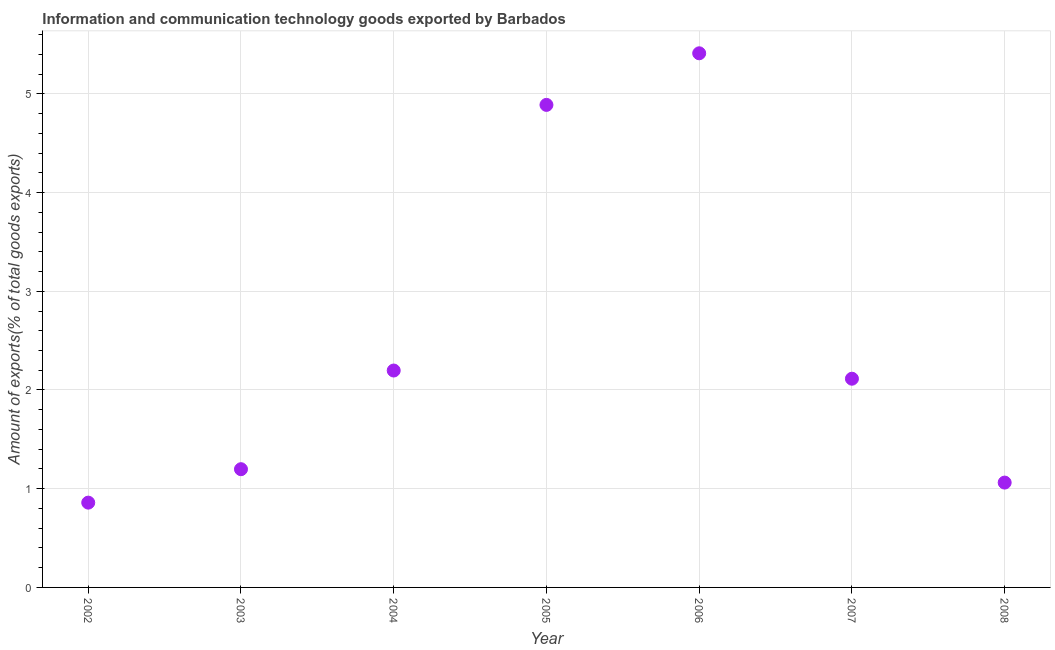What is the amount of ict goods exports in 2007?
Your answer should be compact. 2.11. Across all years, what is the maximum amount of ict goods exports?
Your answer should be compact. 5.41. Across all years, what is the minimum amount of ict goods exports?
Your answer should be compact. 0.86. In which year was the amount of ict goods exports maximum?
Provide a short and direct response. 2006. What is the sum of the amount of ict goods exports?
Offer a very short reply. 17.73. What is the difference between the amount of ict goods exports in 2005 and 2006?
Offer a very short reply. -0.52. What is the average amount of ict goods exports per year?
Your answer should be compact. 2.53. What is the median amount of ict goods exports?
Keep it short and to the point. 2.11. In how many years, is the amount of ict goods exports greater than 0.2 %?
Give a very brief answer. 7. What is the ratio of the amount of ict goods exports in 2002 to that in 2004?
Give a very brief answer. 0.39. Is the difference between the amount of ict goods exports in 2007 and 2008 greater than the difference between any two years?
Provide a short and direct response. No. What is the difference between the highest and the second highest amount of ict goods exports?
Provide a short and direct response. 0.52. Is the sum of the amount of ict goods exports in 2003 and 2008 greater than the maximum amount of ict goods exports across all years?
Make the answer very short. No. What is the difference between the highest and the lowest amount of ict goods exports?
Ensure brevity in your answer.  4.55. In how many years, is the amount of ict goods exports greater than the average amount of ict goods exports taken over all years?
Offer a very short reply. 2. How many years are there in the graph?
Offer a very short reply. 7. Are the values on the major ticks of Y-axis written in scientific E-notation?
Your answer should be very brief. No. Does the graph contain any zero values?
Offer a terse response. No. Does the graph contain grids?
Provide a short and direct response. Yes. What is the title of the graph?
Give a very brief answer. Information and communication technology goods exported by Barbados. What is the label or title of the Y-axis?
Make the answer very short. Amount of exports(% of total goods exports). What is the Amount of exports(% of total goods exports) in 2002?
Make the answer very short. 0.86. What is the Amount of exports(% of total goods exports) in 2003?
Your answer should be compact. 1.2. What is the Amount of exports(% of total goods exports) in 2004?
Give a very brief answer. 2.2. What is the Amount of exports(% of total goods exports) in 2005?
Offer a very short reply. 4.89. What is the Amount of exports(% of total goods exports) in 2006?
Ensure brevity in your answer.  5.41. What is the Amount of exports(% of total goods exports) in 2007?
Ensure brevity in your answer.  2.11. What is the Amount of exports(% of total goods exports) in 2008?
Your answer should be very brief. 1.06. What is the difference between the Amount of exports(% of total goods exports) in 2002 and 2003?
Ensure brevity in your answer.  -0.34. What is the difference between the Amount of exports(% of total goods exports) in 2002 and 2004?
Provide a succinct answer. -1.34. What is the difference between the Amount of exports(% of total goods exports) in 2002 and 2005?
Offer a terse response. -4.03. What is the difference between the Amount of exports(% of total goods exports) in 2002 and 2006?
Make the answer very short. -4.55. What is the difference between the Amount of exports(% of total goods exports) in 2002 and 2007?
Offer a terse response. -1.26. What is the difference between the Amount of exports(% of total goods exports) in 2002 and 2008?
Ensure brevity in your answer.  -0.2. What is the difference between the Amount of exports(% of total goods exports) in 2003 and 2004?
Give a very brief answer. -1. What is the difference between the Amount of exports(% of total goods exports) in 2003 and 2005?
Your answer should be compact. -3.69. What is the difference between the Amount of exports(% of total goods exports) in 2003 and 2006?
Your response must be concise. -4.21. What is the difference between the Amount of exports(% of total goods exports) in 2003 and 2007?
Make the answer very short. -0.92. What is the difference between the Amount of exports(% of total goods exports) in 2003 and 2008?
Provide a succinct answer. 0.14. What is the difference between the Amount of exports(% of total goods exports) in 2004 and 2005?
Offer a very short reply. -2.69. What is the difference between the Amount of exports(% of total goods exports) in 2004 and 2006?
Ensure brevity in your answer.  -3.21. What is the difference between the Amount of exports(% of total goods exports) in 2004 and 2007?
Keep it short and to the point. 0.08. What is the difference between the Amount of exports(% of total goods exports) in 2004 and 2008?
Offer a very short reply. 1.14. What is the difference between the Amount of exports(% of total goods exports) in 2005 and 2006?
Offer a very short reply. -0.52. What is the difference between the Amount of exports(% of total goods exports) in 2005 and 2007?
Provide a short and direct response. 2.77. What is the difference between the Amount of exports(% of total goods exports) in 2005 and 2008?
Provide a short and direct response. 3.83. What is the difference between the Amount of exports(% of total goods exports) in 2006 and 2007?
Offer a very short reply. 3.3. What is the difference between the Amount of exports(% of total goods exports) in 2006 and 2008?
Provide a succinct answer. 4.35. What is the difference between the Amount of exports(% of total goods exports) in 2007 and 2008?
Provide a succinct answer. 1.05. What is the ratio of the Amount of exports(% of total goods exports) in 2002 to that in 2003?
Make the answer very short. 0.72. What is the ratio of the Amount of exports(% of total goods exports) in 2002 to that in 2004?
Provide a succinct answer. 0.39. What is the ratio of the Amount of exports(% of total goods exports) in 2002 to that in 2005?
Provide a short and direct response. 0.18. What is the ratio of the Amount of exports(% of total goods exports) in 2002 to that in 2006?
Your answer should be very brief. 0.16. What is the ratio of the Amount of exports(% of total goods exports) in 2002 to that in 2007?
Offer a very short reply. 0.41. What is the ratio of the Amount of exports(% of total goods exports) in 2002 to that in 2008?
Offer a terse response. 0.81. What is the ratio of the Amount of exports(% of total goods exports) in 2003 to that in 2004?
Your response must be concise. 0.55. What is the ratio of the Amount of exports(% of total goods exports) in 2003 to that in 2005?
Provide a succinct answer. 0.24. What is the ratio of the Amount of exports(% of total goods exports) in 2003 to that in 2006?
Offer a very short reply. 0.22. What is the ratio of the Amount of exports(% of total goods exports) in 2003 to that in 2007?
Provide a short and direct response. 0.57. What is the ratio of the Amount of exports(% of total goods exports) in 2003 to that in 2008?
Your response must be concise. 1.13. What is the ratio of the Amount of exports(% of total goods exports) in 2004 to that in 2005?
Make the answer very short. 0.45. What is the ratio of the Amount of exports(% of total goods exports) in 2004 to that in 2006?
Offer a terse response. 0.41. What is the ratio of the Amount of exports(% of total goods exports) in 2004 to that in 2007?
Your answer should be compact. 1.04. What is the ratio of the Amount of exports(% of total goods exports) in 2004 to that in 2008?
Your answer should be compact. 2.07. What is the ratio of the Amount of exports(% of total goods exports) in 2005 to that in 2006?
Give a very brief answer. 0.9. What is the ratio of the Amount of exports(% of total goods exports) in 2005 to that in 2007?
Your answer should be very brief. 2.31. What is the ratio of the Amount of exports(% of total goods exports) in 2005 to that in 2008?
Ensure brevity in your answer.  4.6. What is the ratio of the Amount of exports(% of total goods exports) in 2006 to that in 2007?
Offer a very short reply. 2.56. What is the ratio of the Amount of exports(% of total goods exports) in 2006 to that in 2008?
Your answer should be very brief. 5.09. What is the ratio of the Amount of exports(% of total goods exports) in 2007 to that in 2008?
Make the answer very short. 1.99. 